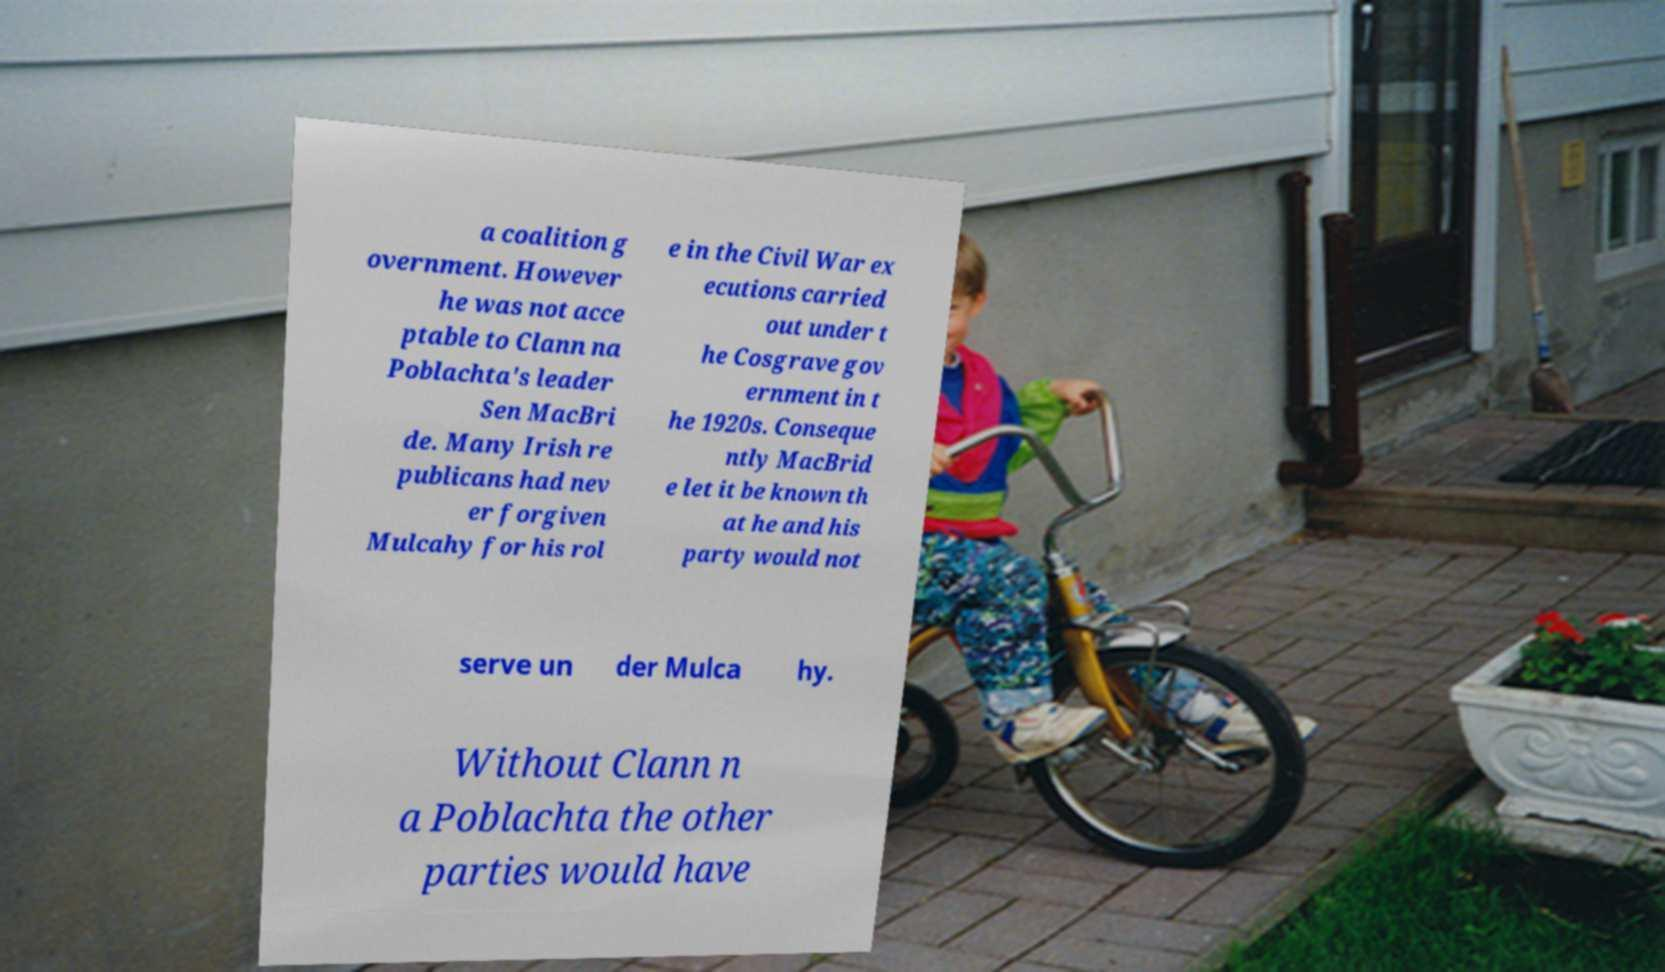What messages or text are displayed in this image? I need them in a readable, typed format. a coalition g overnment. However he was not acce ptable to Clann na Poblachta's leader Sen MacBri de. Many Irish re publicans had nev er forgiven Mulcahy for his rol e in the Civil War ex ecutions carried out under t he Cosgrave gov ernment in t he 1920s. Conseque ntly MacBrid e let it be known th at he and his party would not serve un der Mulca hy. Without Clann n a Poblachta the other parties would have 